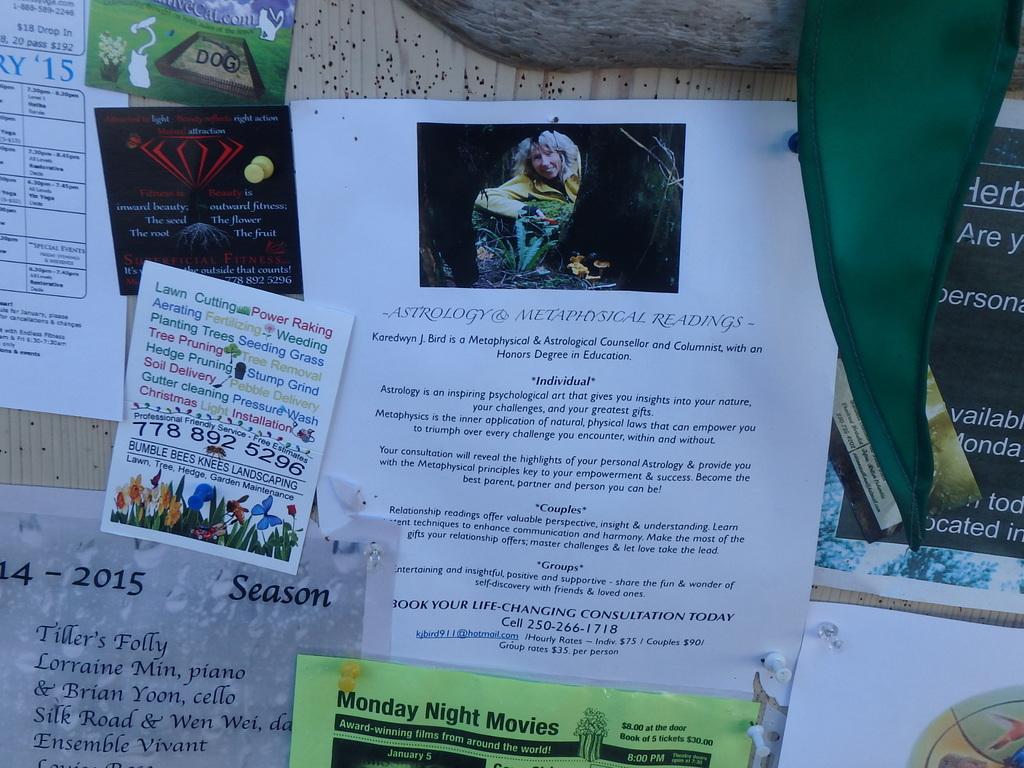What season is it?
Keep it short and to the point. 2015. Is astrology mentioned here?
Your answer should be compact. Yes. 